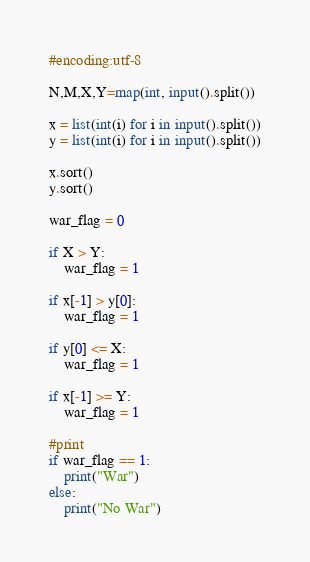Convert code to text. <code><loc_0><loc_0><loc_500><loc_500><_Python_>#encoding:utf-8

N,M,X,Y=map(int, input().split())

x = list(int(i) for i in input().split())
y = list(int(i) for i in input().split())

x.sort()
y.sort()

war_flag = 0

if X > Y:
    war_flag = 1

if x[-1] > y[0]:
    war_flag = 1

if y[0] <= X:
    war_flag = 1

if x[-1] >= Y:
    war_flag = 1

#print
if war_flag == 1:
    print("War")
else:
    print("No War")
</code> 